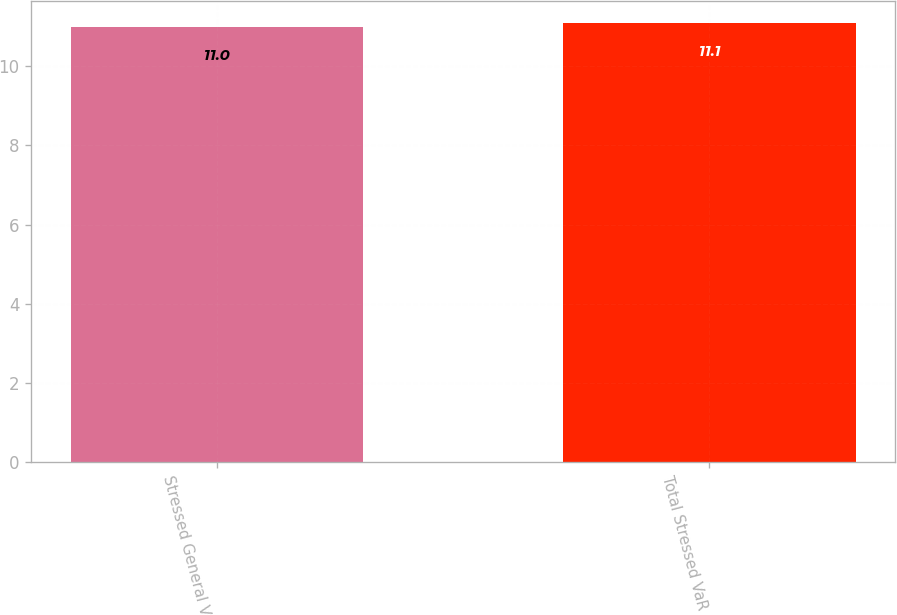Convert chart. <chart><loc_0><loc_0><loc_500><loc_500><bar_chart><fcel>Stressed General VaR<fcel>Total Stressed VaR<nl><fcel>11<fcel>11.1<nl></chart> 